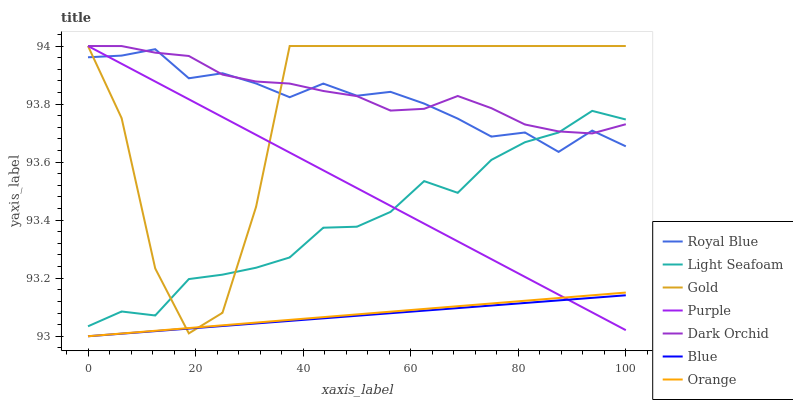Does Blue have the minimum area under the curve?
Answer yes or no. Yes. Does Dark Orchid have the maximum area under the curve?
Answer yes or no. Yes. Does Gold have the minimum area under the curve?
Answer yes or no. No. Does Gold have the maximum area under the curve?
Answer yes or no. No. Is Orange the smoothest?
Answer yes or no. Yes. Is Gold the roughest?
Answer yes or no. Yes. Is Purple the smoothest?
Answer yes or no. No. Is Purple the roughest?
Answer yes or no. No. Does Blue have the lowest value?
Answer yes or no. Yes. Does Gold have the lowest value?
Answer yes or no. No. Does Dark Orchid have the highest value?
Answer yes or no. Yes. Does Royal Blue have the highest value?
Answer yes or no. No. Is Blue less than Light Seafoam?
Answer yes or no. Yes. Is Light Seafoam greater than Orange?
Answer yes or no. Yes. Does Purple intersect Dark Orchid?
Answer yes or no. Yes. Is Purple less than Dark Orchid?
Answer yes or no. No. Is Purple greater than Dark Orchid?
Answer yes or no. No. Does Blue intersect Light Seafoam?
Answer yes or no. No. 